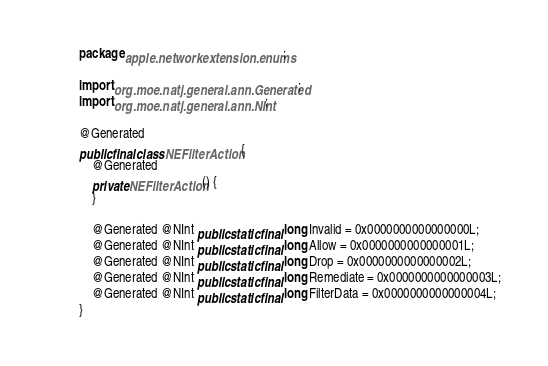<code> <loc_0><loc_0><loc_500><loc_500><_Java_>package apple.networkextension.enums;

import org.moe.natj.general.ann.Generated;
import org.moe.natj.general.ann.NInt;

@Generated
public final class NEFilterAction {
    @Generated
    private NEFilterAction() {
    }

    @Generated @NInt public static final long Invalid = 0x0000000000000000L;
    @Generated @NInt public static final long Allow = 0x0000000000000001L;
    @Generated @NInt public static final long Drop = 0x0000000000000002L;
    @Generated @NInt public static final long Remediate = 0x0000000000000003L;
    @Generated @NInt public static final long FilterData = 0x0000000000000004L;
}</code> 